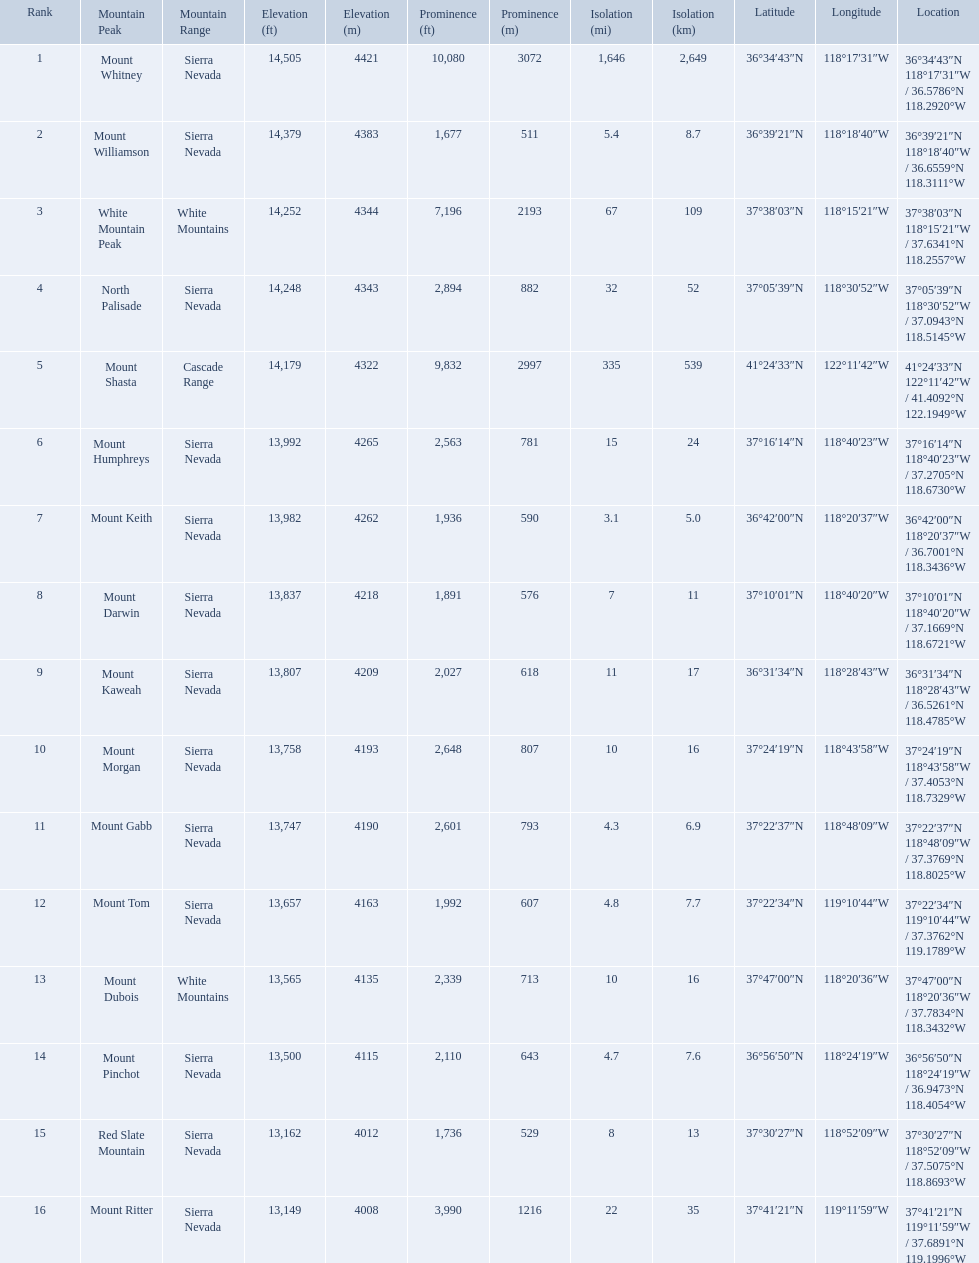What are all of the mountain peaks? Mount Whitney, Mount Williamson, White Mountain Peak, North Palisade, Mount Shasta, Mount Humphreys, Mount Keith, Mount Darwin, Mount Kaweah, Mount Morgan, Mount Gabb, Mount Tom, Mount Dubois, Mount Pinchot, Red Slate Mountain, Mount Ritter. In what ranges are they? Sierra Nevada, Sierra Nevada, White Mountains, Sierra Nevada, Cascade Range, Sierra Nevada, Sierra Nevada, Sierra Nevada, Sierra Nevada, Sierra Nevada, Sierra Nevada, Sierra Nevada, White Mountains, Sierra Nevada, Sierra Nevada, Sierra Nevada. Which peak is in the cascade range? Mount Shasta. Which mountain peaks have a prominence over 9,000 ft? Mount Whitney, Mount Shasta. Of those, which one has the the highest prominence? Mount Whitney. What are the mountain peaks? Mount Whitney, Mount Williamson, White Mountain Peak, North Palisade, Mount Shasta, Mount Humphreys, Mount Keith, Mount Darwin, Mount Kaweah, Mount Morgan, Mount Gabb, Mount Tom, Mount Dubois, Mount Pinchot, Red Slate Mountain, Mount Ritter. Of these, which one has a prominence more than 10,000 ft? Mount Whitney. What are the listed elevations? 14,505 ft\n4421 m, 14,379 ft\n4383 m, 14,252 ft\n4344 m, 14,248 ft\n4343 m, 14,179 ft\n4322 m, 13,992 ft\n4265 m, 13,982 ft\n4262 m, 13,837 ft\n4218 m, 13,807 ft\n4209 m, 13,758 ft\n4193 m, 13,747 ft\n4190 m, 13,657 ft\n4163 m, 13,565 ft\n4135 m, 13,500 ft\n4115 m, 13,162 ft\n4012 m, 13,149 ft\n4008 m. Which of those is 13,149 ft or below? 13,149 ft\n4008 m. To what mountain peak does that value correspond? Mount Ritter. Can you give me this table in json format? {'header': ['Rank', 'Mountain Peak', 'Mountain Range', 'Elevation (ft)', 'Elevation (m)', 'Prominence (ft)', 'Prominence (m)', 'Isolation (mi)', 'Isolation (km)', 'Latitude', 'Longitude', 'Location'], 'rows': [['1', 'Mount Whitney', 'Sierra Nevada', '14,505', '4421', '10,080', '3072', '1,646', '2,649', '36°34′43″N', '118°17′31″W\ufeff', '36°34′43″N 118°17′31″W\ufeff / \ufeff36.5786°N 118.2920°W'], ['2', 'Mount Williamson', 'Sierra Nevada', '14,379', '4383', '1,677', '511', '5.4', '8.7', '36°39′21″N', '118°18′40″W\ufeff', '36°39′21″N 118°18′40″W\ufeff / \ufeff36.6559°N 118.3111°W'], ['3', 'White Mountain Peak', 'White Mountains', '14,252', '4344', '7,196', '2193', '67', '109', '37°38′03″N', '118°15′21″W\ufeff', '37°38′03″N 118°15′21″W\ufeff / \ufeff37.6341°N 118.2557°W'], ['4', 'North Palisade', 'Sierra Nevada', '14,248', '4343', '2,894', '882', '32', '52', '37°05′39″N', '118°30′52″W\ufeff', '37°05′39″N 118°30′52″W\ufeff / \ufeff37.0943°N 118.5145°W'], ['5', 'Mount Shasta', 'Cascade Range', '14,179', '4322', '9,832', '2997', '335', '539', '41°24′33″N', '122°11′42″W\ufeff', '41°24′33″N 122°11′42″W\ufeff / \ufeff41.4092°N 122.1949°W'], ['6', 'Mount Humphreys', 'Sierra Nevada', '13,992', '4265', '2,563', '781', '15', '24', '37°16′14″N', '118°40′23″W\ufeff', '37°16′14″N 118°40′23″W\ufeff / \ufeff37.2705°N 118.6730°W'], ['7', 'Mount Keith', 'Sierra Nevada', '13,982', '4262', '1,936', '590', '3.1', '5.0', '36°42′00″N', '118°20′37″W\ufeff', '36°42′00″N 118°20′37″W\ufeff / \ufeff36.7001°N 118.3436°W'], ['8', 'Mount Darwin', 'Sierra Nevada', '13,837', '4218', '1,891', '576', '7', '11', '37°10′01″N', '118°40′20″W\ufeff', '37°10′01″N 118°40′20″W\ufeff / \ufeff37.1669°N 118.6721°W'], ['9', 'Mount Kaweah', 'Sierra Nevada', '13,807', '4209', '2,027', '618', '11', '17', '36°31′34″N', '118°28′43″W\ufeff', '36°31′34″N 118°28′43″W\ufeff / \ufeff36.5261°N 118.4785°W'], ['10', 'Mount Morgan', 'Sierra Nevada', '13,758', '4193', '2,648', '807', '10', '16', '37°24′19″N', '118°43′58″W\ufeff', '37°24′19″N 118°43′58″W\ufeff / \ufeff37.4053°N 118.7329°W'], ['11', 'Mount Gabb', 'Sierra Nevada', '13,747', '4190', '2,601', '793', '4.3', '6.9', '37°22′37″N', '118°48′09″W\ufeff', '37°22′37″N 118°48′09″W\ufeff / \ufeff37.3769°N 118.8025°W'], ['12', 'Mount Tom', 'Sierra Nevada', '13,657', '4163', '1,992', '607', '4.8', '7.7', '37°22′34″N', '119°10′44″W\ufeff', '37°22′34″N 119°10′44″W\ufeff / \ufeff37.3762°N 119.1789°W'], ['13', 'Mount Dubois', 'White Mountains', '13,565', '4135', '2,339', '713', '10', '16', '37°47′00″N', '118°20′36″W\ufeff', '37°47′00″N 118°20′36″W\ufeff / \ufeff37.7834°N 118.3432°W'], ['14', 'Mount Pinchot', 'Sierra Nevada', '13,500', '4115', '2,110', '643', '4.7', '7.6', '36°56′50″N', '118°24′19″W\ufeff', '36°56′50″N 118°24′19″W\ufeff / \ufeff36.9473°N 118.4054°W'], ['15', 'Red Slate Mountain', 'Sierra Nevada', '13,162', '4012', '1,736', '529', '8', '13', '37°30′27″N', '118°52′09″W\ufeff', '37°30′27″N 118°52′09″W\ufeff / \ufeff37.5075°N 118.8693°W'], ['16', 'Mount Ritter', 'Sierra Nevada', '13,149', '4008', '3,990', '1216', '22', '35', '37°41′21″N', '119°11′59″W\ufeff', '37°41′21″N 119°11′59″W\ufeff / \ufeff37.6891°N 119.1996°W']]} Which mountain peaks are lower than 14,000 ft? Mount Humphreys, Mount Keith, Mount Darwin, Mount Kaweah, Mount Morgan, Mount Gabb, Mount Tom, Mount Dubois, Mount Pinchot, Red Slate Mountain, Mount Ritter. Are any of them below 13,500? if so, which ones? Red Slate Mountain, Mount Ritter. What's the lowest peak? 13,149 ft\n4008 m. Which one is that? Mount Ritter. What are all of the peaks? Mount Whitney, Mount Williamson, White Mountain Peak, North Palisade, Mount Shasta, Mount Humphreys, Mount Keith, Mount Darwin, Mount Kaweah, Mount Morgan, Mount Gabb, Mount Tom, Mount Dubois, Mount Pinchot, Red Slate Mountain, Mount Ritter. Where are they located? Sierra Nevada, Sierra Nevada, White Mountains, Sierra Nevada, Cascade Range, Sierra Nevada, Sierra Nevada, Sierra Nevada, Sierra Nevada, Sierra Nevada, Sierra Nevada, Sierra Nevada, White Mountains, Sierra Nevada, Sierra Nevada, Sierra Nevada. How tall are they? 14,505 ft\n4421 m, 14,379 ft\n4383 m, 14,252 ft\n4344 m, 14,248 ft\n4343 m, 14,179 ft\n4322 m, 13,992 ft\n4265 m, 13,982 ft\n4262 m, 13,837 ft\n4218 m, 13,807 ft\n4209 m, 13,758 ft\n4193 m, 13,747 ft\n4190 m, 13,657 ft\n4163 m, 13,565 ft\n4135 m, 13,500 ft\n4115 m, 13,162 ft\n4012 m, 13,149 ft\n4008 m. What about just the peaks in the sierra nevadas? 14,505 ft\n4421 m, 14,379 ft\n4383 m, 14,248 ft\n4343 m, 13,992 ft\n4265 m, 13,982 ft\n4262 m, 13,837 ft\n4218 m, 13,807 ft\n4209 m, 13,758 ft\n4193 m, 13,747 ft\n4190 m, 13,657 ft\n4163 m, 13,500 ft\n4115 m, 13,162 ft\n4012 m, 13,149 ft\n4008 m. And of those, which is the tallest? Mount Whitney. 